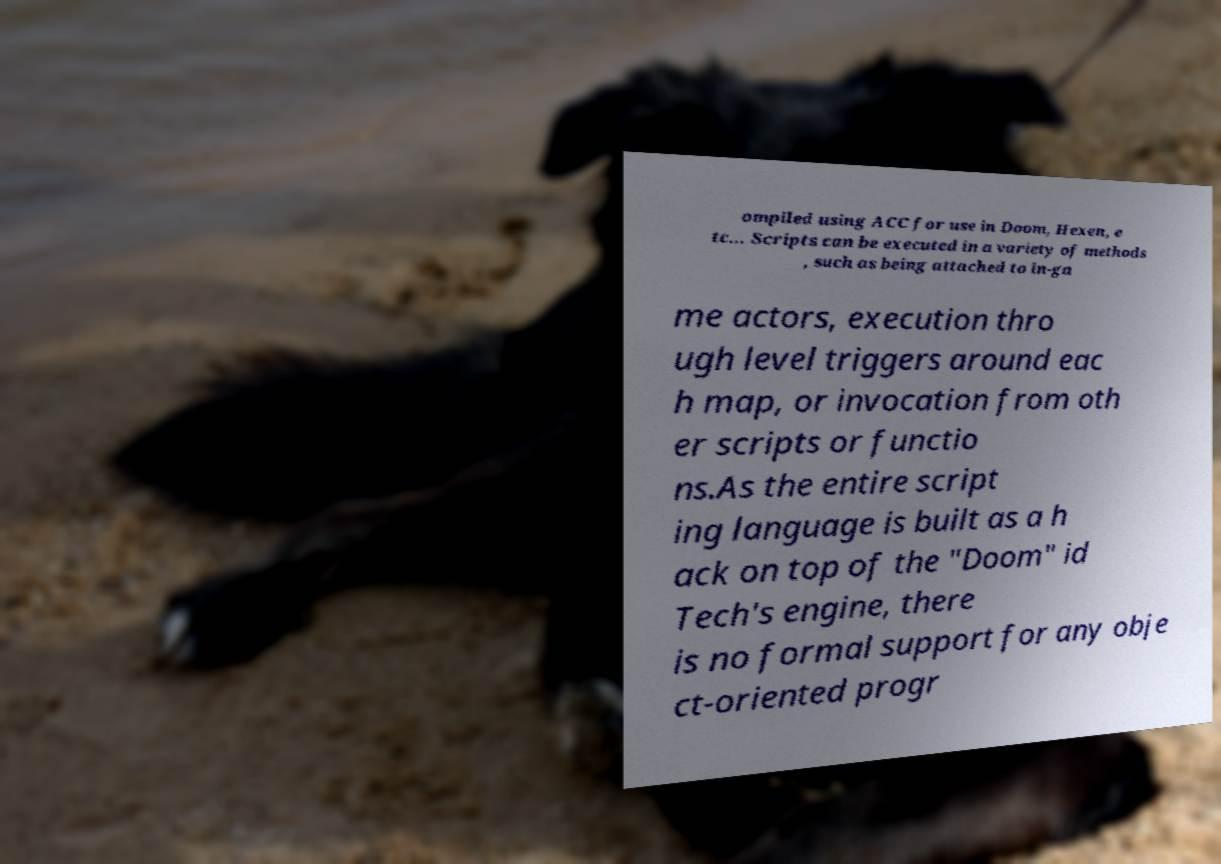Can you accurately transcribe the text from the provided image for me? ompiled using ACC for use in Doom, Hexen, e tc... Scripts can be executed in a variety of methods , such as being attached to in-ga me actors, execution thro ugh level triggers around eac h map, or invocation from oth er scripts or functio ns.As the entire script ing language is built as a h ack on top of the "Doom" id Tech's engine, there is no formal support for any obje ct-oriented progr 